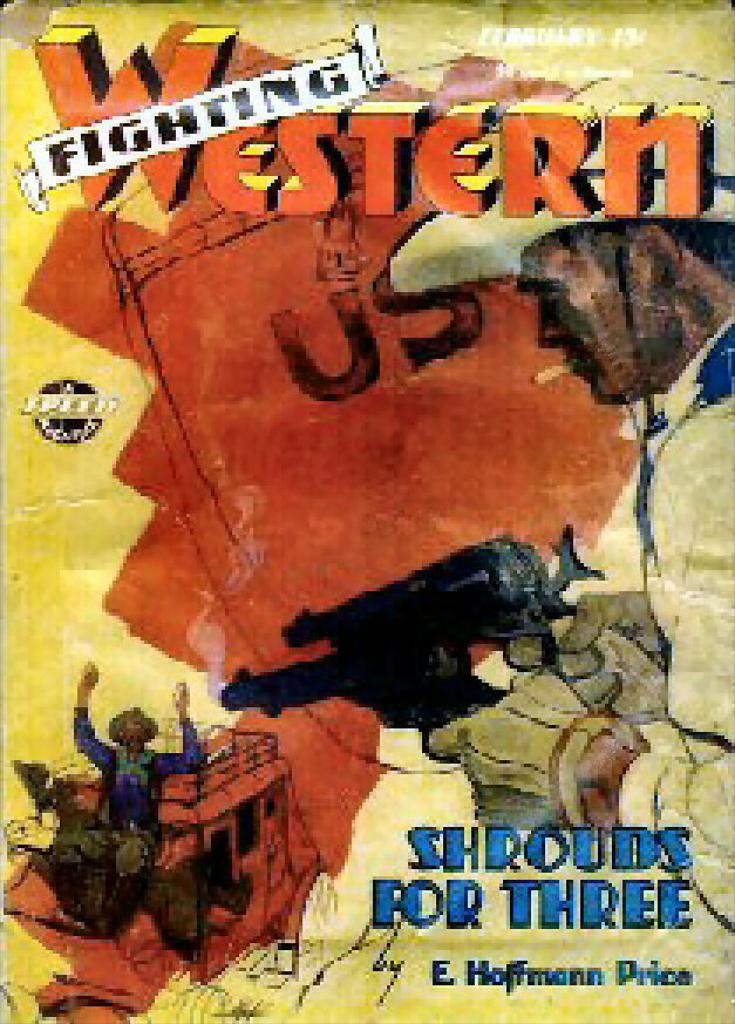<image>
Describe the image concisely. Animated cover of Fighting Western series called Shrouds For Three. 